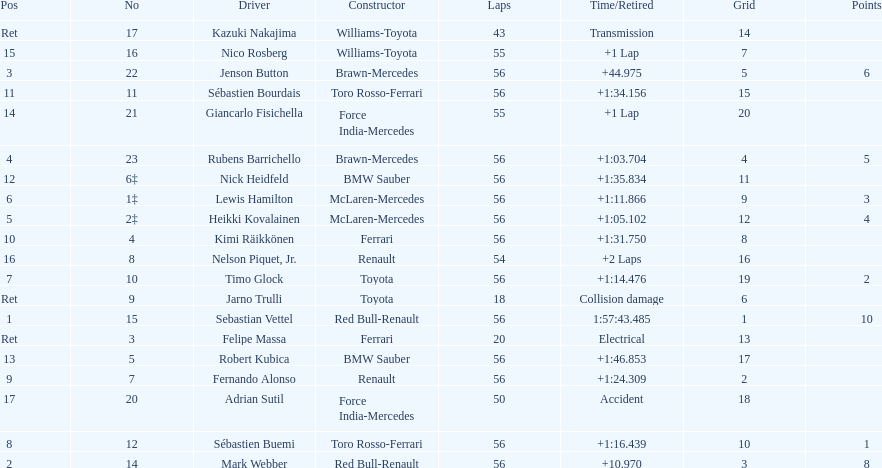Could you parse the entire table as a dict? {'header': ['Pos', 'No', 'Driver', 'Constructor', 'Laps', 'Time/Retired', 'Grid', 'Points'], 'rows': [['Ret', '17', 'Kazuki Nakajima', 'Williams-Toyota', '43', 'Transmission', '14', ''], ['15', '16', 'Nico Rosberg', 'Williams-Toyota', '55', '+1 Lap', '7', ''], ['3', '22', 'Jenson Button', 'Brawn-Mercedes', '56', '+44.975', '5', '6'], ['11', '11', 'Sébastien Bourdais', 'Toro Rosso-Ferrari', '56', '+1:34.156', '15', ''], ['14', '21', 'Giancarlo Fisichella', 'Force India-Mercedes', '55', '+1 Lap', '20', ''], ['4', '23', 'Rubens Barrichello', 'Brawn-Mercedes', '56', '+1:03.704', '4', '5'], ['12', '6‡', 'Nick Heidfeld', 'BMW Sauber', '56', '+1:35.834', '11', ''], ['6', '1‡', 'Lewis Hamilton', 'McLaren-Mercedes', '56', '+1:11.866', '9', '3'], ['5', '2‡', 'Heikki Kovalainen', 'McLaren-Mercedes', '56', '+1:05.102', '12', '4'], ['10', '4', 'Kimi Räikkönen', 'Ferrari', '56', '+1:31.750', '8', ''], ['16', '8', 'Nelson Piquet, Jr.', 'Renault', '54', '+2 Laps', '16', ''], ['7', '10', 'Timo Glock', 'Toyota', '56', '+1:14.476', '19', '2'], ['Ret', '9', 'Jarno Trulli', 'Toyota', '18', 'Collision damage', '6', ''], ['1', '15', 'Sebastian Vettel', 'Red Bull-Renault', '56', '1:57:43.485', '1', '10'], ['Ret', '3', 'Felipe Massa', 'Ferrari', '20', 'Electrical', '13', ''], ['13', '5', 'Robert Kubica', 'BMW Sauber', '56', '+1:46.853', '17', ''], ['9', '7', 'Fernando Alonso', 'Renault', '56', '+1:24.309', '2', ''], ['17', '20', 'Adrian Sutil', 'Force India-Mercedes', '50', 'Accident', '18', ''], ['8', '12', 'Sébastien Buemi', 'Toro Rosso-Ferrari', '56', '+1:16.439', '10', '1'], ['2', '14', 'Mark Webber', 'Red Bull-Renault', '56', '+10.970', '3', '8']]} Heikki kovalainen and lewis hamilton both had which constructor? McLaren-Mercedes. 